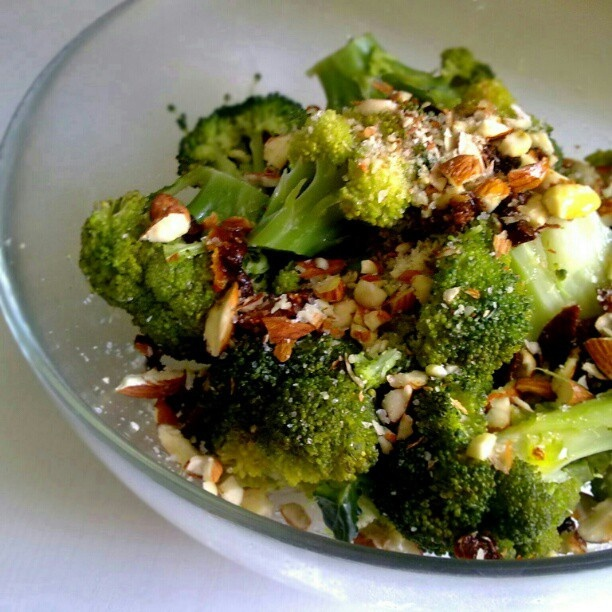Describe the objects in this image and their specific colors. I can see bowl in black, olive, and darkgray tones, broccoli in darkgray, black, and olive tones, broccoli in darkgray, black, and olive tones, broccoli in darkgray, darkgreen, black, and olive tones, and broccoli in darkgray, olive, and black tones in this image. 